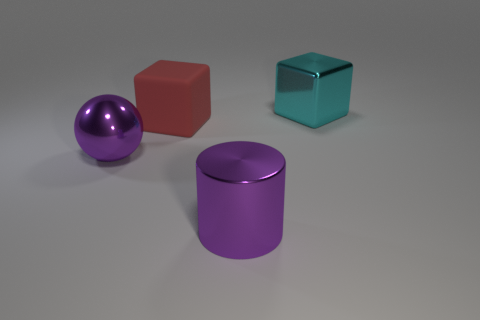What number of shiny objects are either big purple objects or brown objects?
Your response must be concise. 2. What material is the red thing?
Your answer should be compact. Rubber. What is the material of the block on the left side of the purple metal thing in front of the purple object on the left side of the big rubber thing?
Provide a succinct answer. Rubber. There is a cyan metallic object that is the same size as the red matte object; what shape is it?
Your response must be concise. Cube. How many things are brown cylinders or blocks that are in front of the metal cube?
Ensure brevity in your answer.  1. Is the material of the block in front of the cyan metal object the same as the big purple object in front of the large shiny ball?
Offer a very short reply. No. There is a object that is the same color as the big metallic cylinder; what shape is it?
Keep it short and to the point. Sphere. What number of purple things are either large metal cylinders or metallic balls?
Make the answer very short. 2. Are there more big objects behind the large purple metal sphere than purple shiny spheres?
Offer a terse response. Yes. How many rubber cubes are behind the large cyan thing?
Ensure brevity in your answer.  0. 